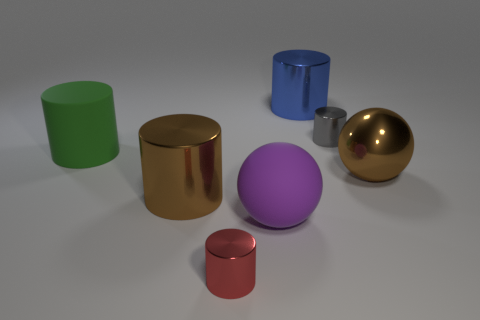Subtract all small cylinders. How many cylinders are left? 3 Add 3 small gray things. How many objects exist? 10 Subtract all blue cylinders. How many cylinders are left? 4 Subtract all cylinders. How many objects are left? 2 Subtract all big metal cylinders. Subtract all yellow cylinders. How many objects are left? 5 Add 1 matte balls. How many matte balls are left? 2 Add 1 tiny cylinders. How many tiny cylinders exist? 3 Subtract 1 green cylinders. How many objects are left? 6 Subtract 5 cylinders. How many cylinders are left? 0 Subtract all brown balls. Subtract all cyan cylinders. How many balls are left? 1 